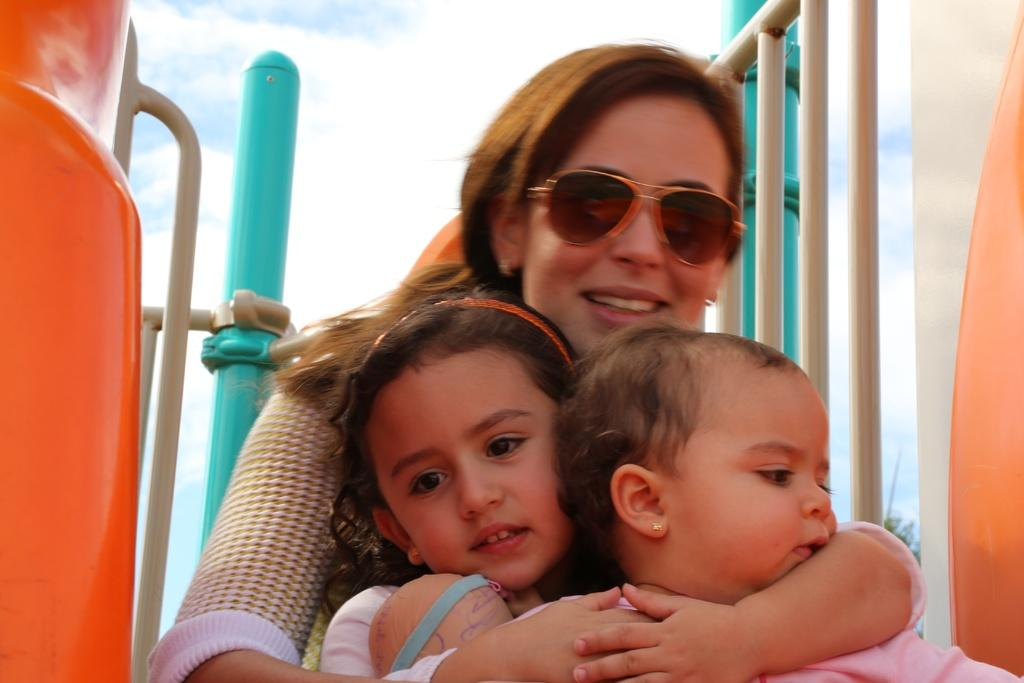Who is the main subject in the image? There is a woman in the image. Are there any other people in the image besides the woman? Yes, there are two kids in the image. What is the woman wearing on her face? The woman is wearing goggles. What can be seen at the top of the image? The sky is visible at the top of the image. What type of bottle and pot are used in the magic trick performed by the woman in the image? There is no bottle or pot present in the image, and the woman is not performing any magic tricks. 